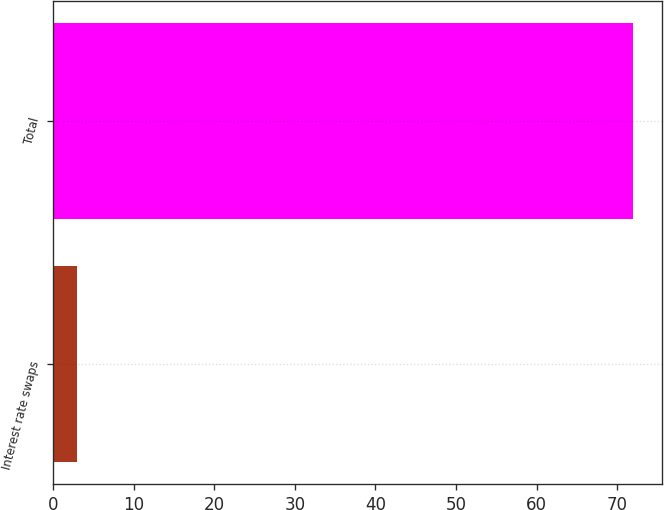<chart> <loc_0><loc_0><loc_500><loc_500><bar_chart><fcel>Interest rate swaps<fcel>Total<nl><fcel>3<fcel>72<nl></chart> 